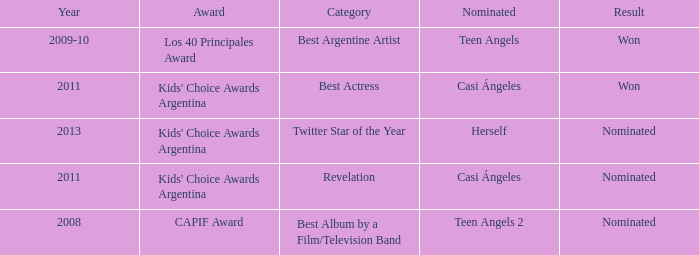For what award was there a nomination for Best Actress? Kids' Choice Awards Argentina. 